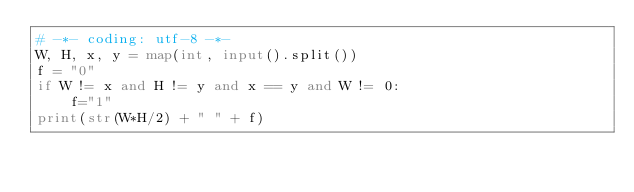<code> <loc_0><loc_0><loc_500><loc_500><_Python_># -*- coding: utf-8 -*-
W, H, x, y = map(int, input().split())
f = "0"
if W != x and H != y and x == y and W != 0:
    f="1"
print(str(W*H/2) + " " + f)

</code> 